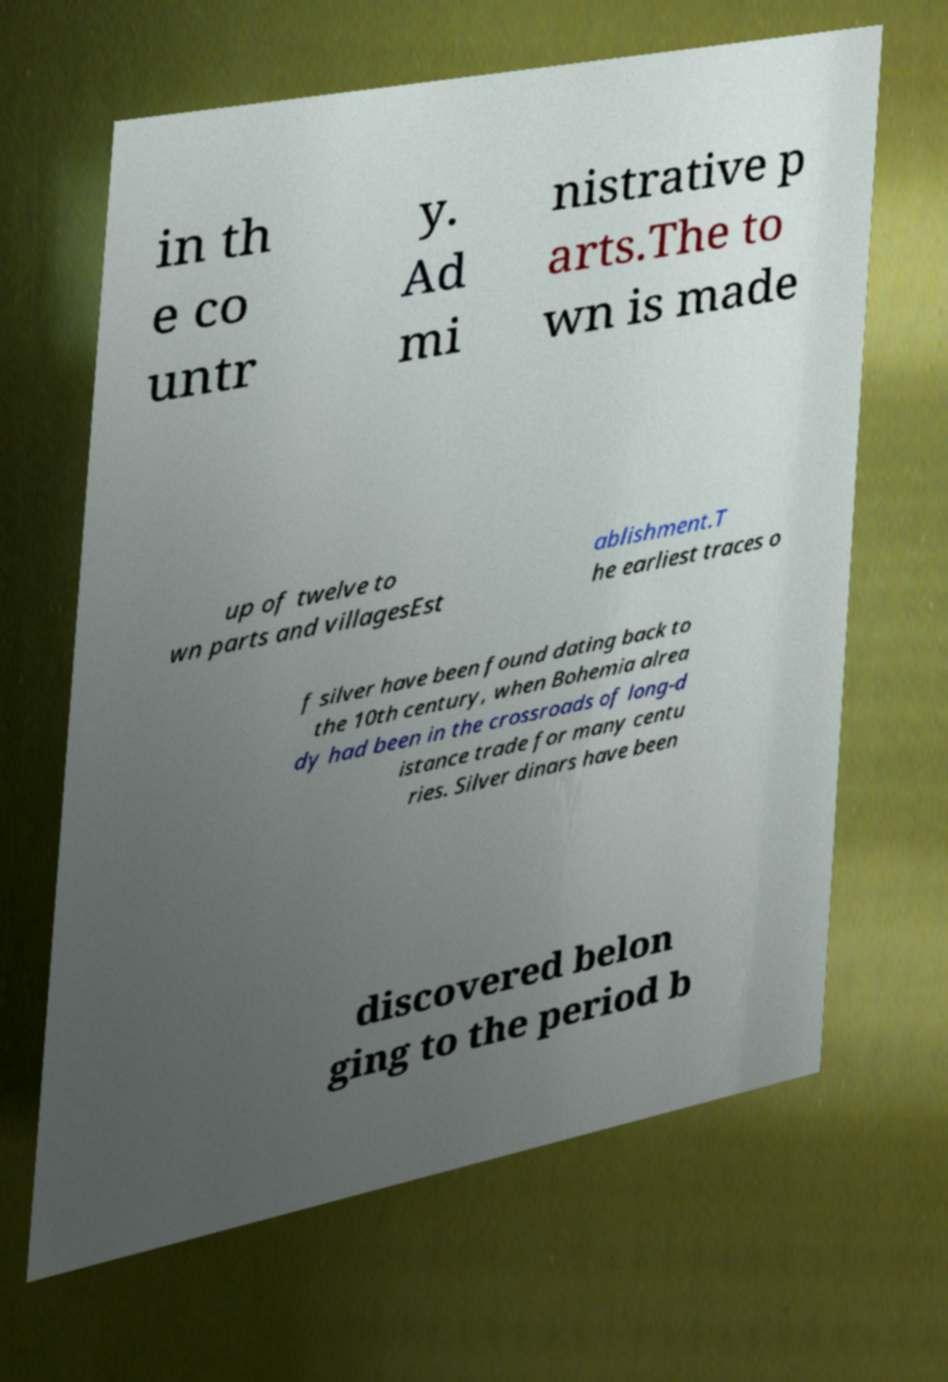Please identify and transcribe the text found in this image. in th e co untr y. Ad mi nistrative p arts.The to wn is made up of twelve to wn parts and villagesEst ablishment.T he earliest traces o f silver have been found dating back to the 10th century, when Bohemia alrea dy had been in the crossroads of long-d istance trade for many centu ries. Silver dinars have been discovered belon ging to the period b 